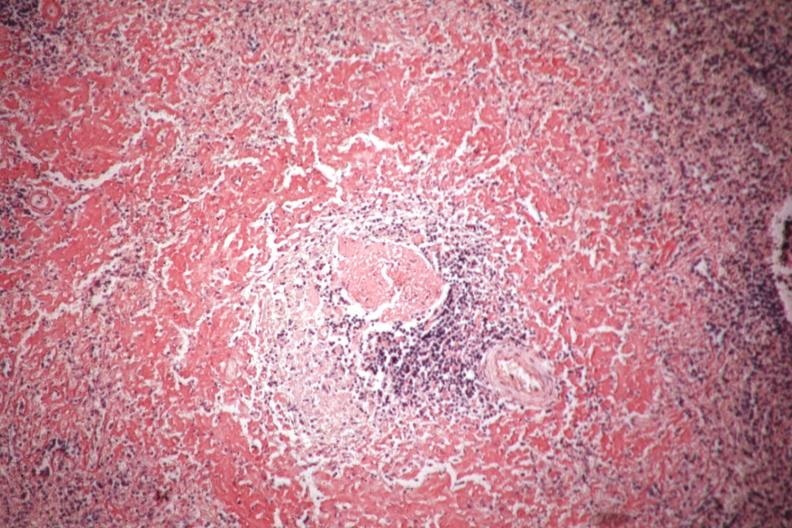s spleen present?
Answer the question using a single word or phrase. Yes 